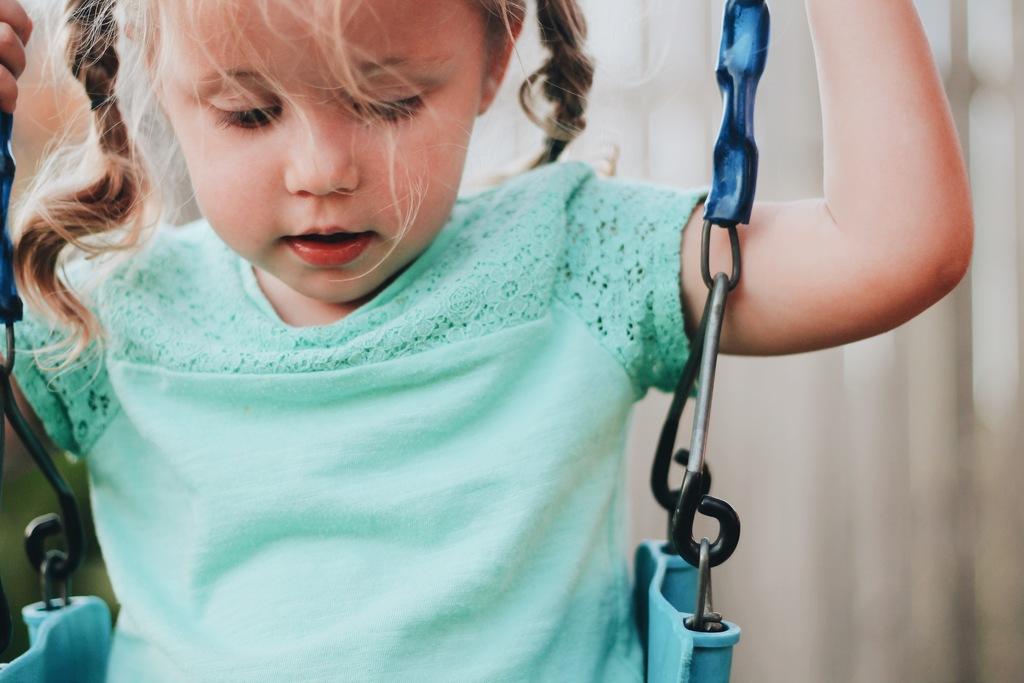Could you give a brief overview of what you see in this image? In this image there is a girl sitting on the swing. 